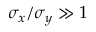<formula> <loc_0><loc_0><loc_500><loc_500>\sigma _ { x } / \sigma _ { y } \gg 1</formula> 